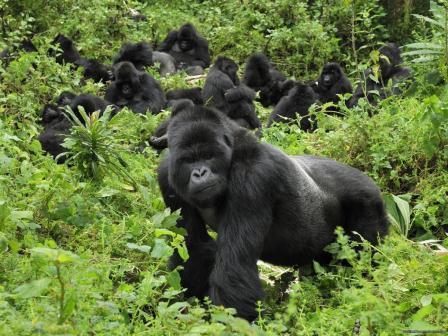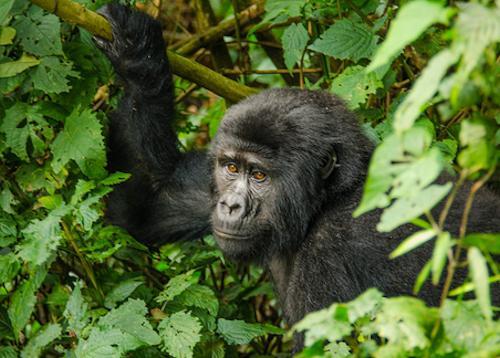The first image is the image on the left, the second image is the image on the right. Considering the images on both sides, is "The right image contains no more than two gorillas." valid? Answer yes or no. Yes. The first image is the image on the left, the second image is the image on the right. Evaluate the accuracy of this statement regarding the images: "In at least one image there is a baby gorilla trying to hold onto the back of a large gorilla.". Is it true? Answer yes or no. No. 